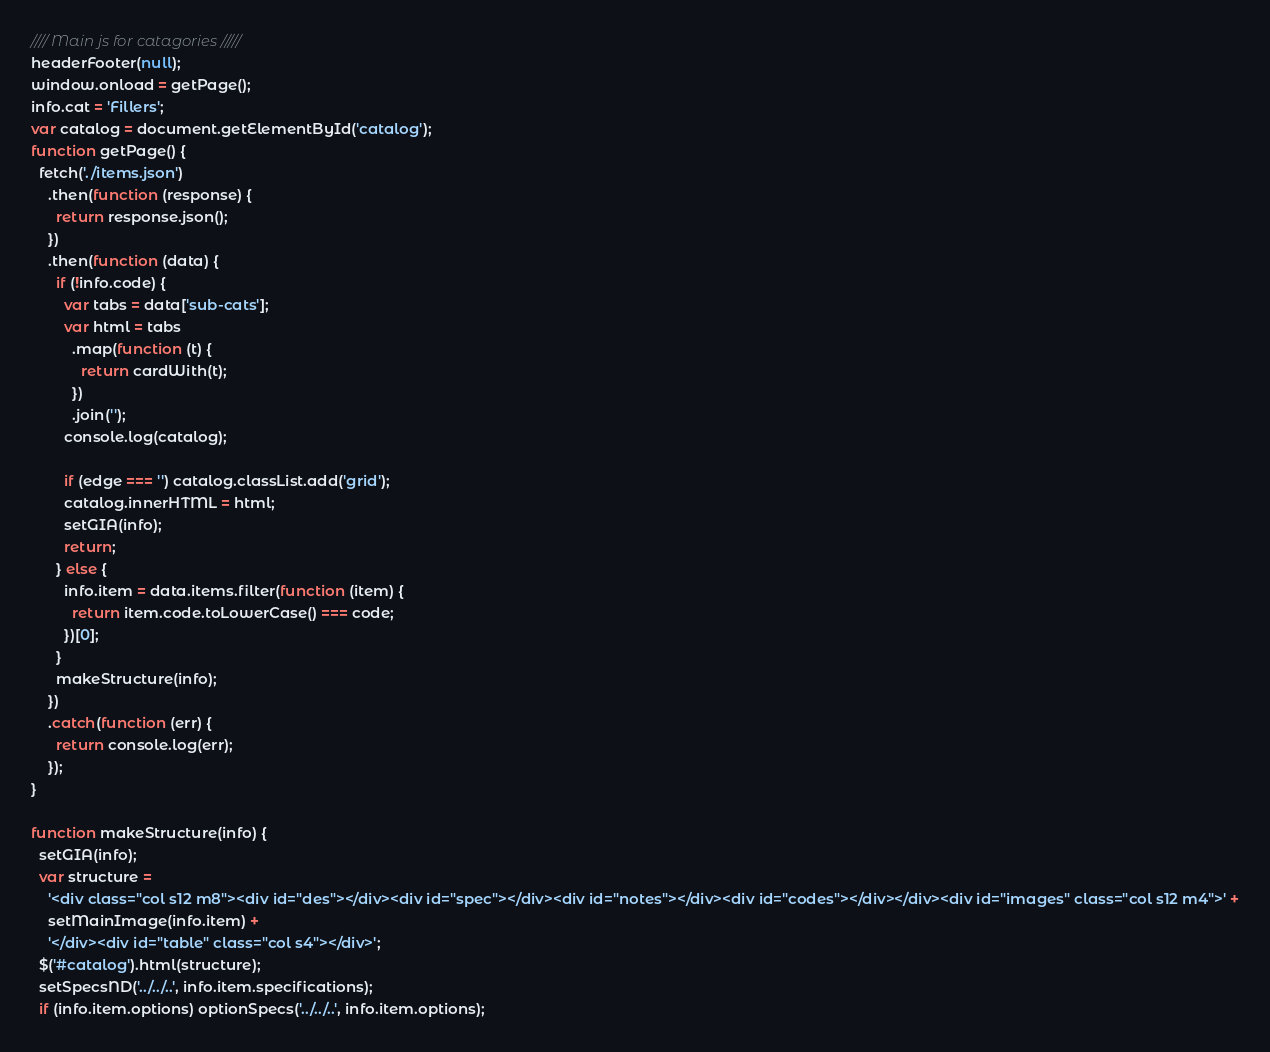<code> <loc_0><loc_0><loc_500><loc_500><_JavaScript_>//// Main js for catagories /////
headerFooter(null);
window.onload = getPage();
info.cat = 'Fillers';
var catalog = document.getElementById('catalog');
function getPage() {
  fetch('./items.json')
    .then(function (response) {
      return response.json();
    })
    .then(function (data) {
      if (!info.code) {
        var tabs = data['sub-cats'];
        var html = tabs
          .map(function (t) {
            return cardWith(t);
          })
          .join('');
        console.log(catalog);

        if (edge === '') catalog.classList.add('grid');
        catalog.innerHTML = html;
        setGIA(info);
        return;
      } else {
        info.item = data.items.filter(function (item) {
          return item.code.toLowerCase() === code;
        })[0];
      }
      makeStructure(info);
    })
    .catch(function (err) {
      return console.log(err);
    });
}

function makeStructure(info) {
  setGIA(info);
  var structure =
    '<div class="col s12 m8"><div id="des"></div><div id="spec"></div><div id="notes"></div><div id="codes"></div></div><div id="images" class="col s12 m4">' +
    setMainImage(info.item) +
    '</div><div id="table" class="col s4"></div>';
  $('#catalog').html(structure);
  setSpecsND('../../..', info.item.specifications);
  if (info.item.options) optionSpecs('../../..', info.item.options);</code> 